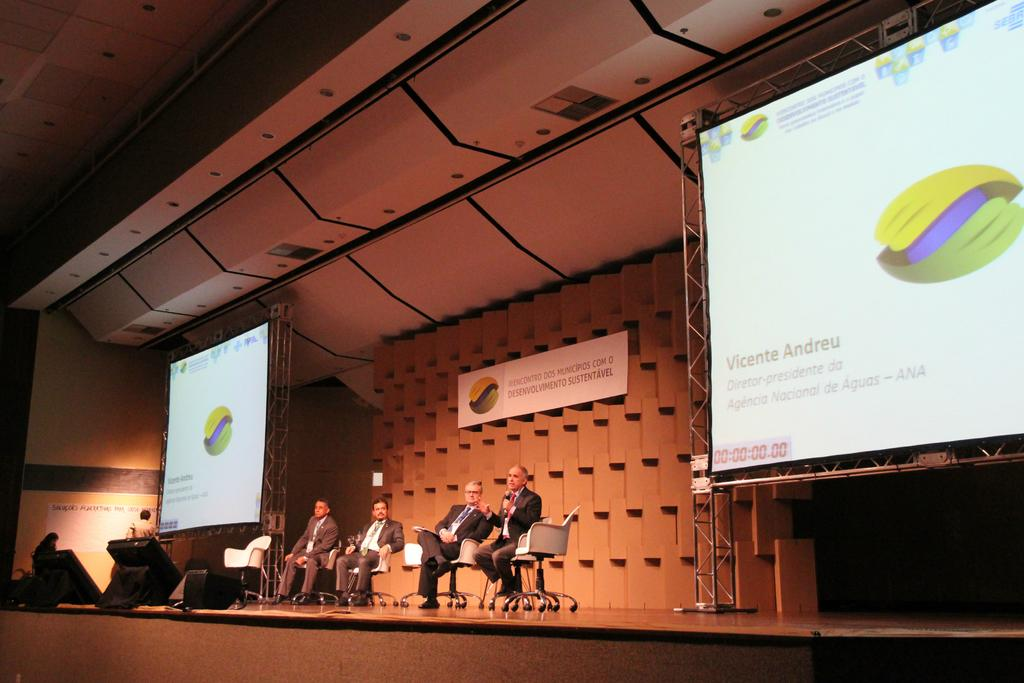Who or what can be seen in the image? There are people in the image. What are the people doing in the image? The people are sitting on chairs. What objects are present in the image that might be used for displaying information or visuals? There are two projector screens in the image. What type of sponge is being used for a game of chess in the image? There is no sponge or game of chess present in the image. 